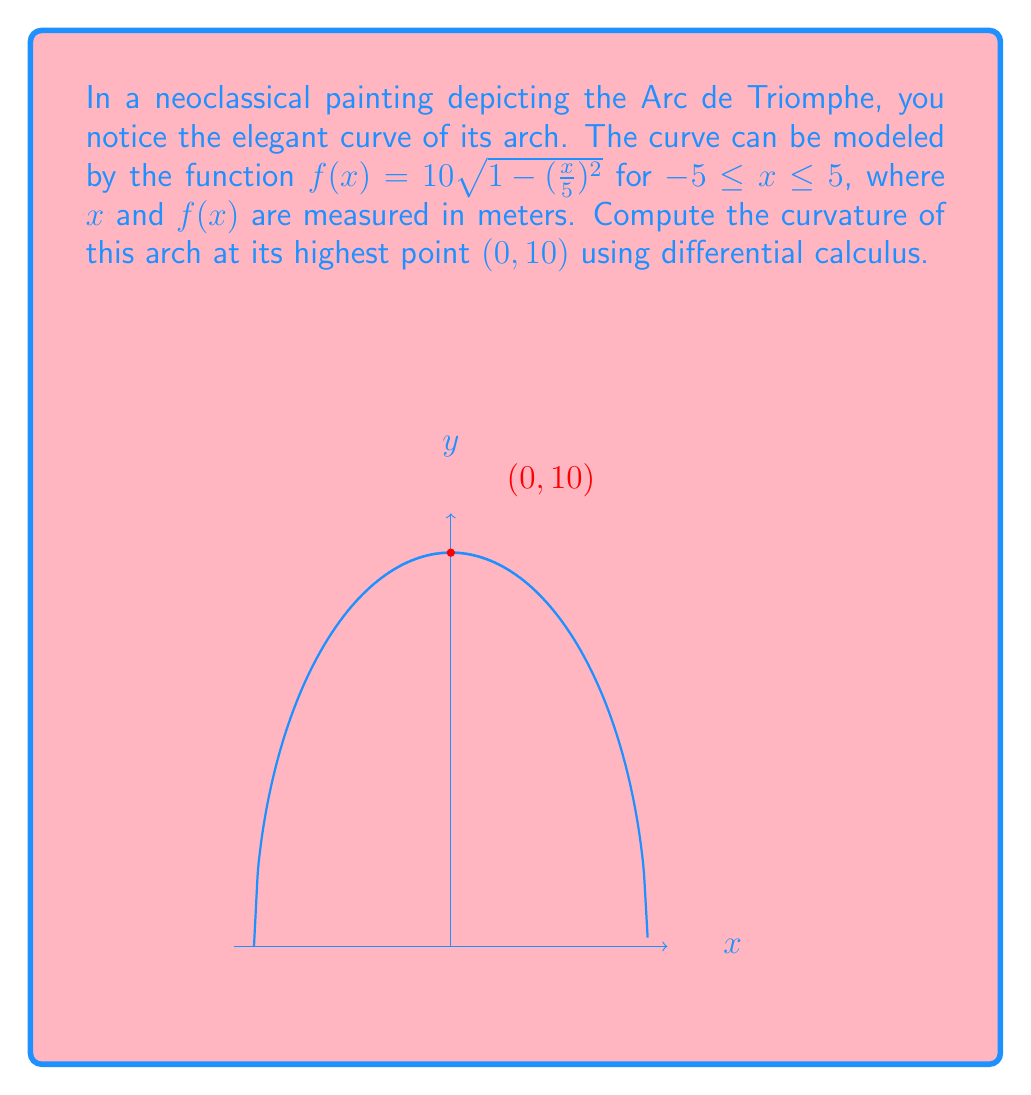Solve this math problem. To find the curvature at a point, we use the formula:

$$\kappa = \frac{|f''(x)|}{(1 + [f'(x)]^2)^{3/2}}$$

Step 1: Find $f'(x)$
$$f'(x) = 10 \cdot \frac{1}{2\sqrt{1-(\frac{x}{5})^2}} \cdot (-2\frac{x}{25}) = -\frac{x}{5\sqrt{1-(\frac{x}{5})^2}}$$

Step 2: Find $f''(x)$
$$f''(x) = -\frac{1}{5\sqrt{1-(\frac{x}{5})^2}} - \frac{x^2}{25(1-(\frac{x}{5})^2)^{3/2}}$$

Step 3: Evaluate $f'(0)$ and $f''(0)$
$$f'(0) = 0$$
$$f''(0) = -\frac{1}{5}$$

Step 4: Apply the curvature formula
$$\kappa = \frac{|\frac{1}{5}|}{(1 + 0^2)^{3/2}} = \frac{1}{5}$$

Therefore, the curvature of the arch at its highest point $(0, 10)$ is $\frac{1}{5}$ m⁻¹.
Answer: $\frac{1}{5}$ m⁻¹ 